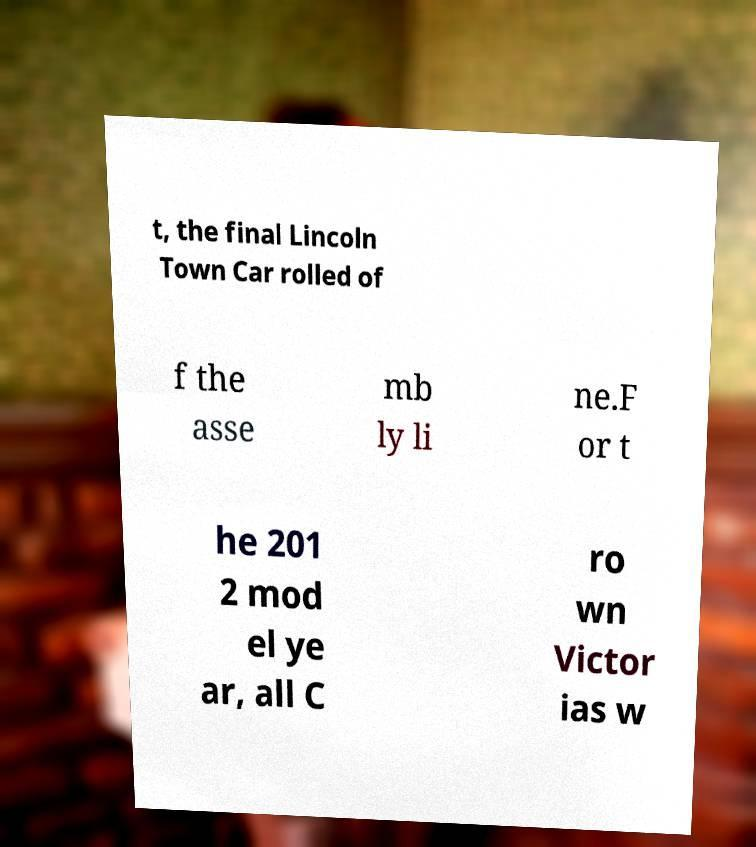What messages or text are displayed in this image? I need them in a readable, typed format. t, the final Lincoln Town Car rolled of f the asse mb ly li ne.F or t he 201 2 mod el ye ar, all C ro wn Victor ias w 